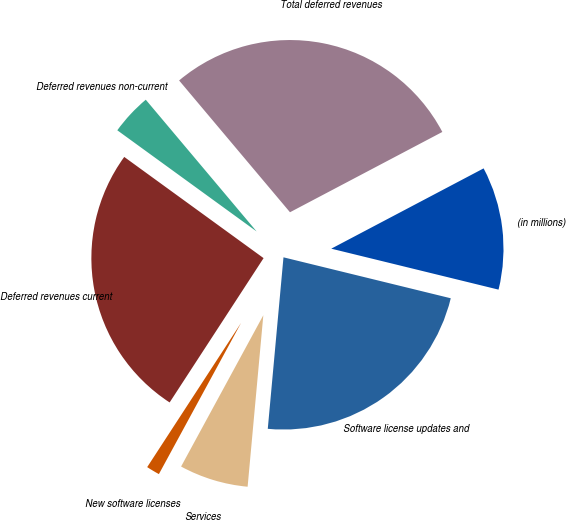Convert chart to OTSL. <chart><loc_0><loc_0><loc_500><loc_500><pie_chart><fcel>(in millions)<fcel>Software license updates and<fcel>Services<fcel>New software licenses<fcel>Deferred revenues current<fcel>Deferred revenues non-current<fcel>Total deferred revenues<nl><fcel>11.54%<fcel>22.63%<fcel>6.47%<fcel>1.26%<fcel>25.81%<fcel>3.87%<fcel>28.41%<nl></chart> 